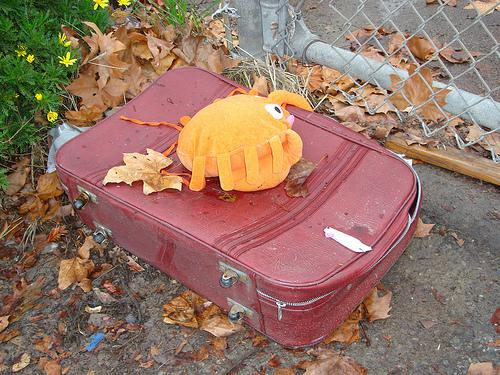Question: how many wheels are on the suitcase?
Choices:
A. Two.
B. Three.
C. Four.
D. Six.
Answer with the letter. Answer: C Question: what color are the flowers?
Choices:
A. White.
B. Yellow.
C. Blue.
D. Purple.
Answer with the letter. Answer: B Question: when was this photo taken?
Choices:
A. Nighttime.
B. Daytime.
C. Afternoon.
D. Morning.
Answer with the letter. Answer: B Question: what color is the suitcase?
Choices:
A. Red.
B. Yellow.
C. Black.
D. Brown.
Answer with the letter. Answer: A Question: what color is the largest item that is on the suitcase?
Choices:
A. White.
B. Red.
C. Black.
D. Orange.
Answer with the letter. Answer: D 